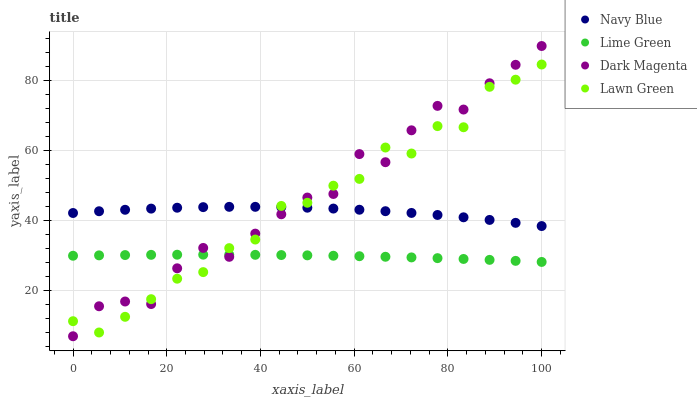Does Lime Green have the minimum area under the curve?
Answer yes or no. Yes. Does Dark Magenta have the maximum area under the curve?
Answer yes or no. Yes. Does Dark Magenta have the minimum area under the curve?
Answer yes or no. No. Does Lime Green have the maximum area under the curve?
Answer yes or no. No. Is Lime Green the smoothest?
Answer yes or no. Yes. Is Dark Magenta the roughest?
Answer yes or no. Yes. Is Dark Magenta the smoothest?
Answer yes or no. No. Is Lime Green the roughest?
Answer yes or no. No. Does Dark Magenta have the lowest value?
Answer yes or no. Yes. Does Lime Green have the lowest value?
Answer yes or no. No. Does Dark Magenta have the highest value?
Answer yes or no. Yes. Does Lime Green have the highest value?
Answer yes or no. No. Is Lime Green less than Navy Blue?
Answer yes or no. Yes. Is Navy Blue greater than Lime Green?
Answer yes or no. Yes. Does Lime Green intersect Lawn Green?
Answer yes or no. Yes. Is Lime Green less than Lawn Green?
Answer yes or no. No. Is Lime Green greater than Lawn Green?
Answer yes or no. No. Does Lime Green intersect Navy Blue?
Answer yes or no. No. 